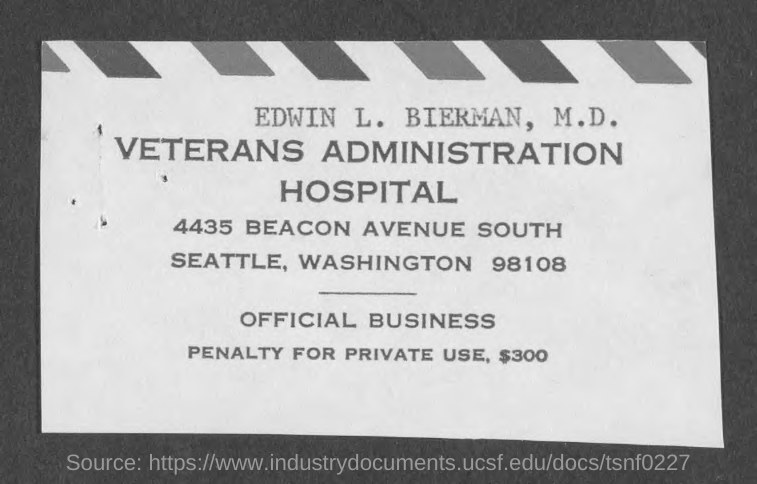In which state is the veterans administration hospital?
Make the answer very short. Washington. How much is the penalty for private use?
Your answer should be compact. $300. What the name mentioned in the document?
Offer a very short reply. Edwin L. Bierman. 